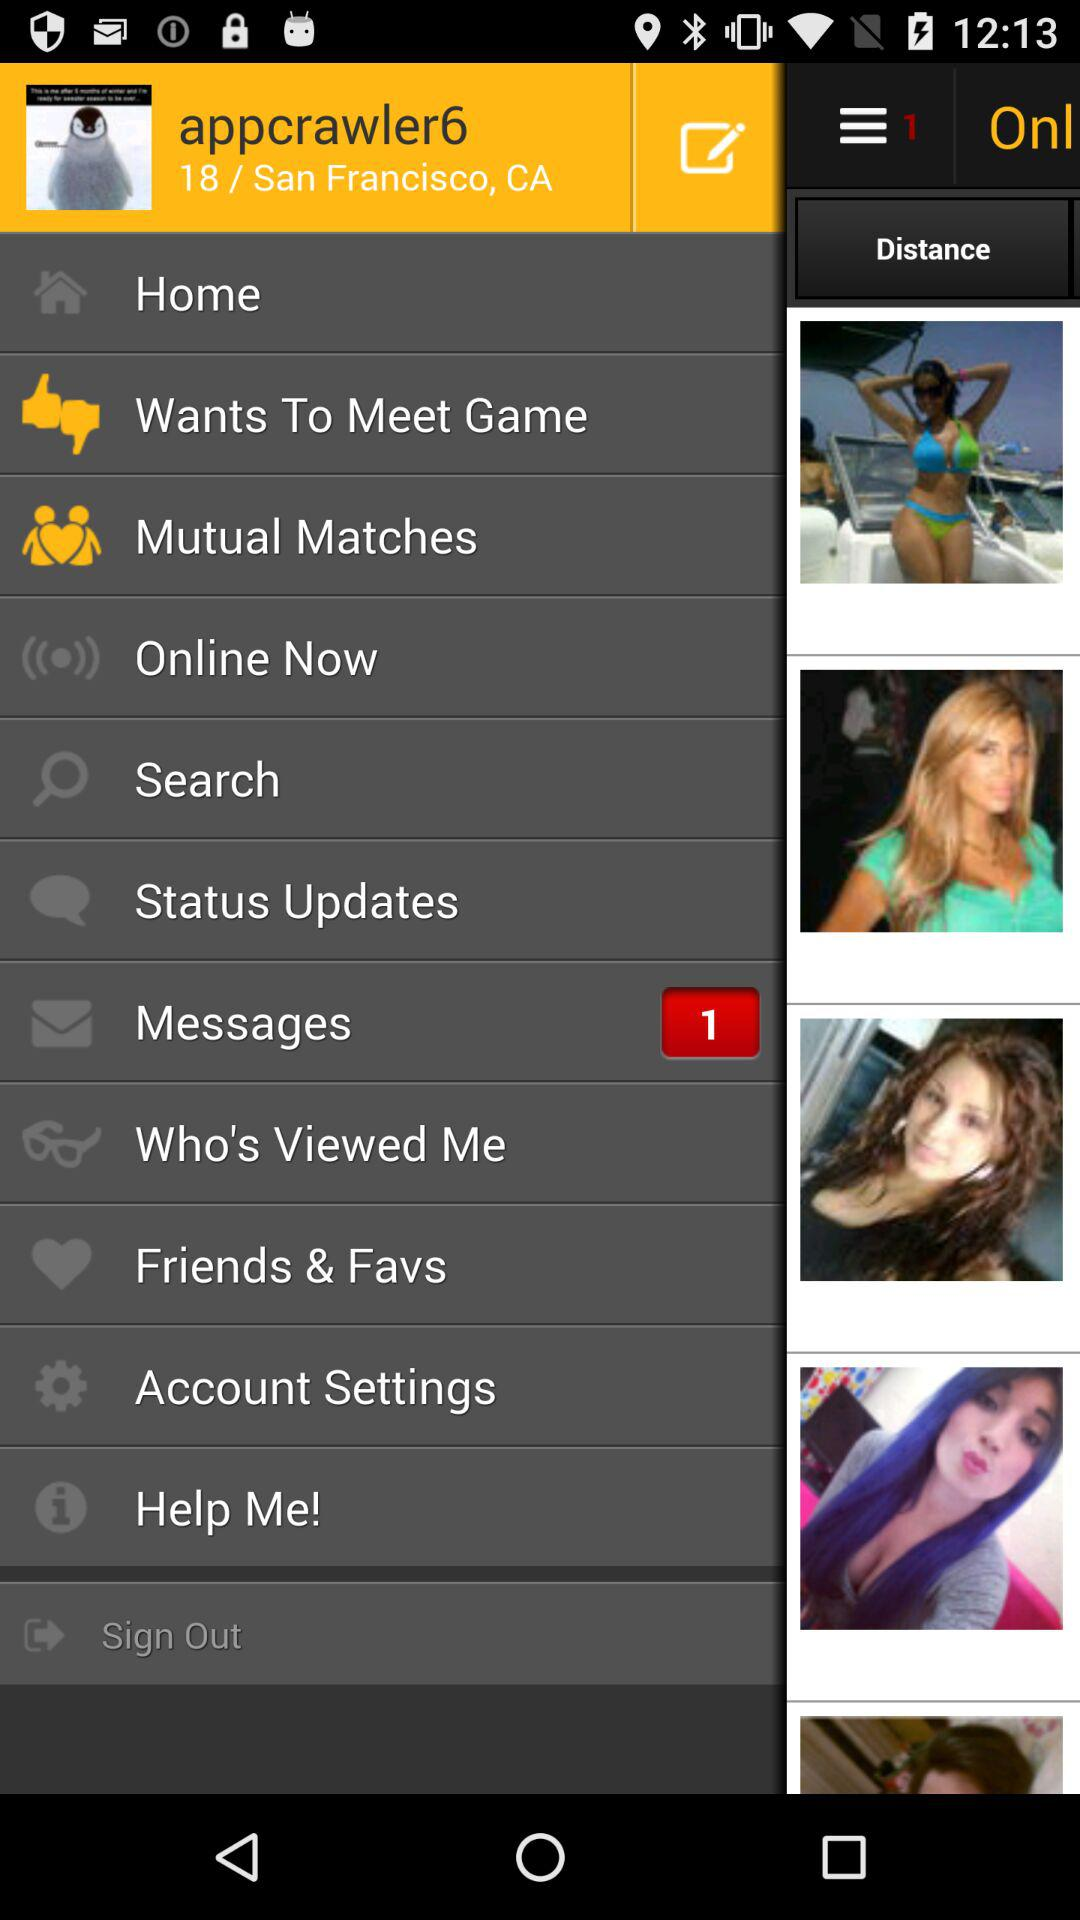How many messages are unread? There is 1 unread message. 